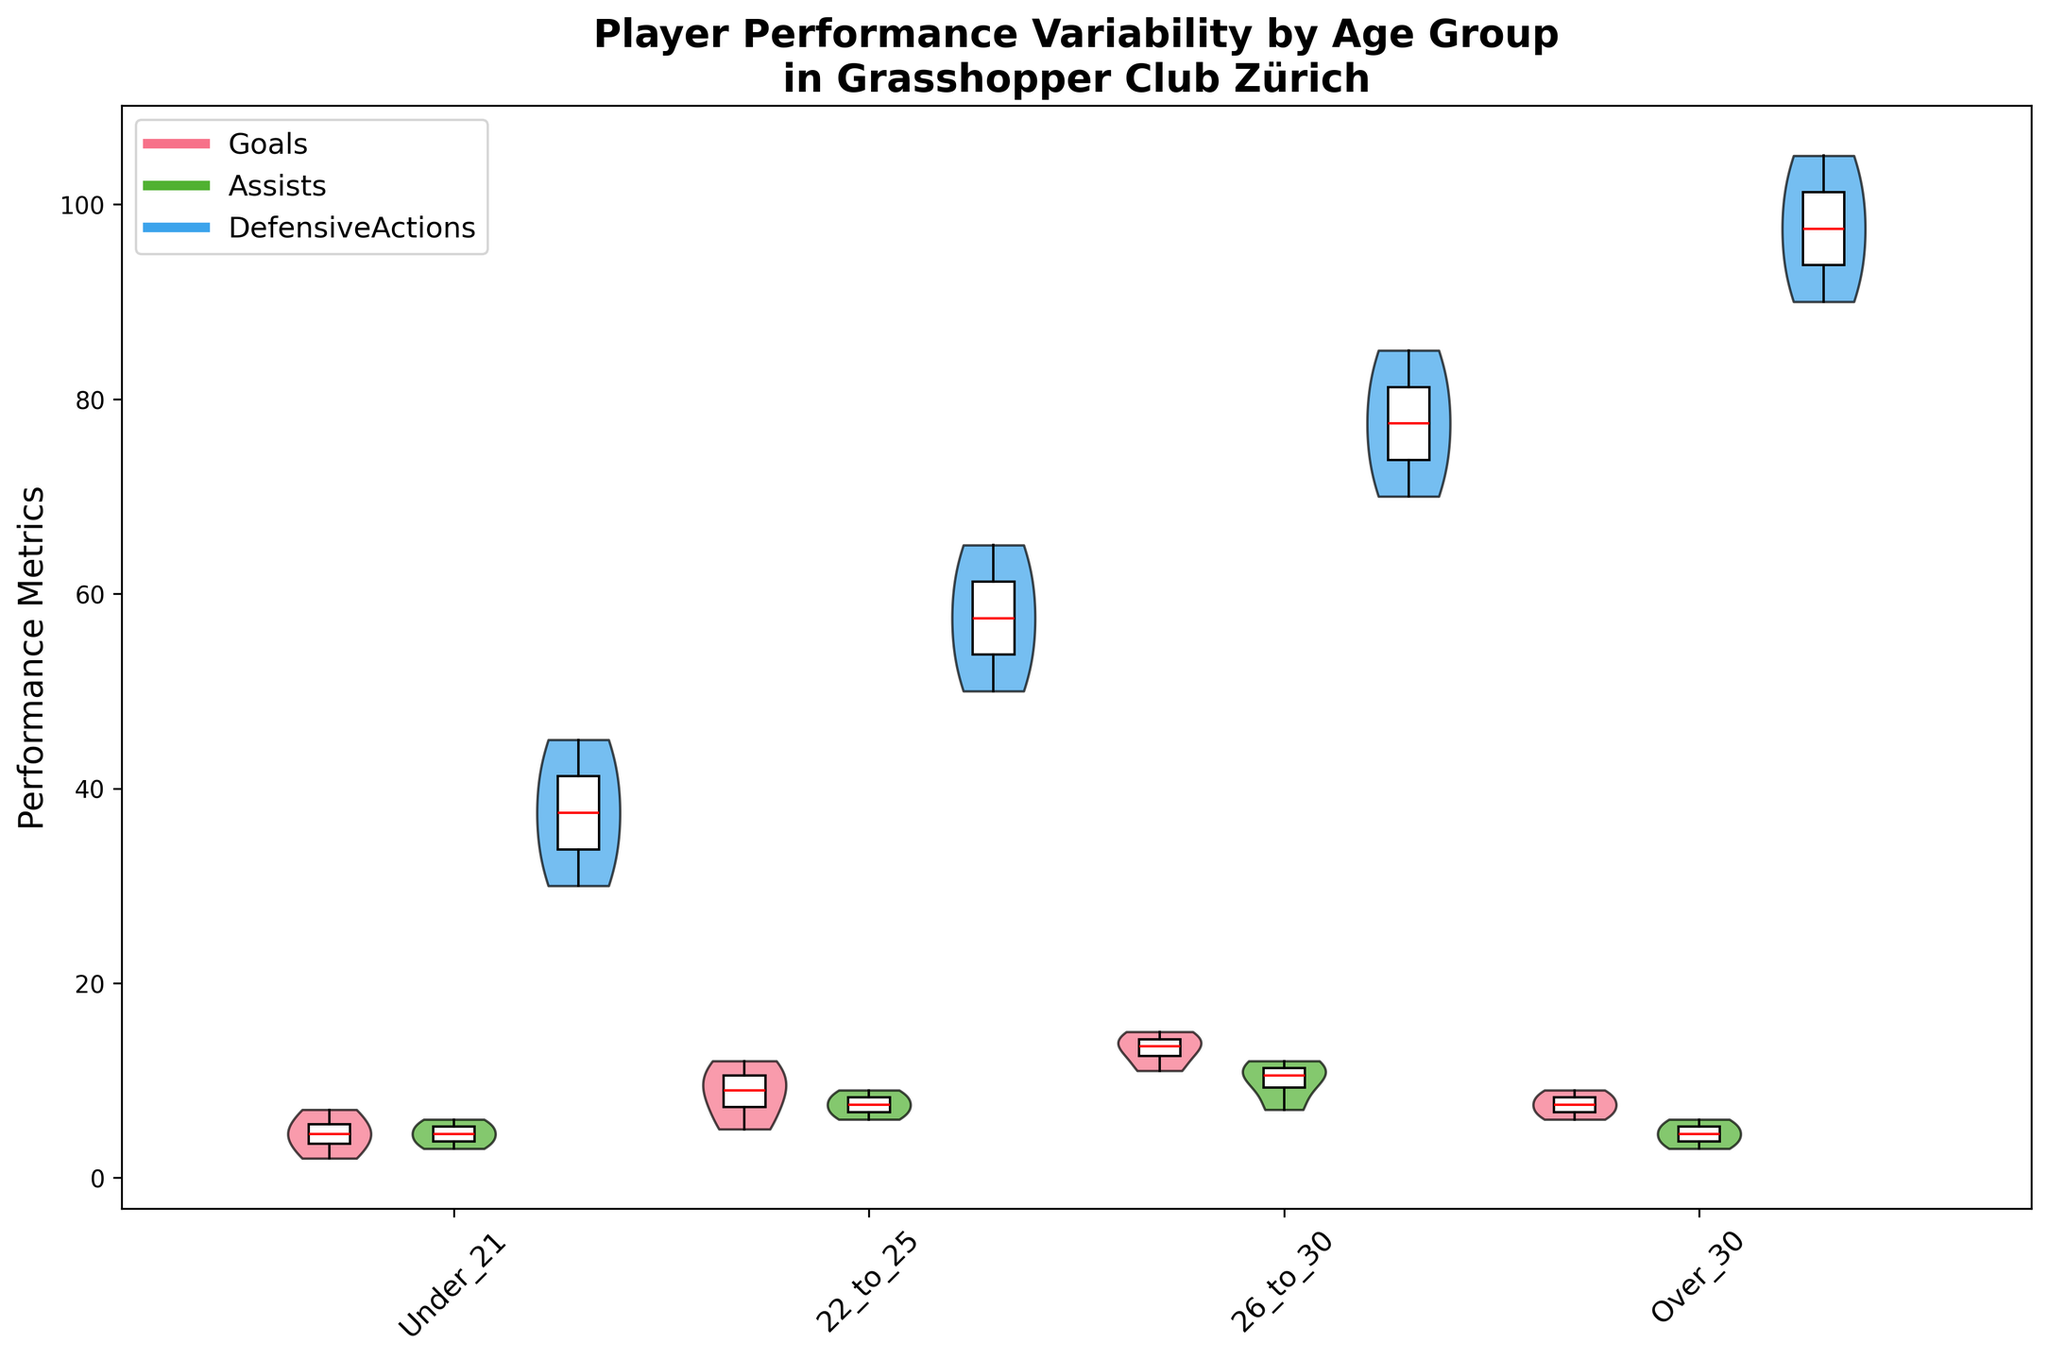What's the title of the figure? The title is usually located at the top of the figure. In this case, it is explicitly given as part of generating the figure.
Answer: Player Performance Variability by Age Group in Grasshopper Club Zürich What are the performance metrics displayed in the figure? The legend at the top left of the figure shows the metrics, which are represented by colors in the violin plots and box plots.
Answer: Goals, Assists, Defensive Actions Which age group has the highest median number of defensive actions? To find the median, look for the red line in the box plots overlaying the violins. In the "Over_30" age group, the red median line in the defensive actions' box plot is the highest compared to other age groups.
Answer: Over_30 How does the spread of goals compare between the Under_21 and Over_30 age groups? Observe the width and shape of the goal's violin plot and the range of box plots. The spread is represented by the width at different points. The Under_21 group has a wider spread, indicating greater variability.
Answer: Under_21 has a wider spread Which age group has the highest variability in assists? Examine the shape and width of the violin plots for assists across age groups. The Under_21 age group has the thickest violin plot for assists, indicating higher variability.
Answer: Under_21 How many age groups are included in the figure? The x-axis labels indicate the age groups. Counting them, we have four labels.
Answer: Four What's the average number of goals for players aged 22 to 25? The box plot for the 22_to_25 age group shows the distribution, and the white patches represent the average values. Summing the values for 22_to_25: (10+8+12+5)/4 = 35/4 = 8.75
Answer: 8.75 Which performance metric shows the least variability for the 26_to_30 age group? Observe the violin plots for 26_to_30. The narrowest one indicates the least variability. The assists metric is the thinnest among Goals, Assists, and DefensiveActions.
Answer: Assists Compare the median number of assists between the 22_to_25 and 26_to_30 age groups. Look at the red median lines in the box plots for assists. The 26_to_30 age group's median line is higher than the 22_to_25 group.
Answer: 26_to_30 has a higher median What colors represent the performance metrics on the violin plots? The legend shows the colors assigned to each performance metric.
Answer: Goals, Assists, Defensive Actions 